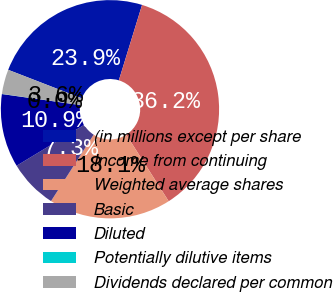Convert chart. <chart><loc_0><loc_0><loc_500><loc_500><pie_chart><fcel>(in millions except per share<fcel>Income from continuing<fcel>Weighted average shares<fcel>Basic<fcel>Diluted<fcel>Potentially dilutive items<fcel>Dividends declared per common<nl><fcel>23.87%<fcel>36.21%<fcel>18.12%<fcel>7.26%<fcel>10.88%<fcel>0.02%<fcel>3.64%<nl></chart> 